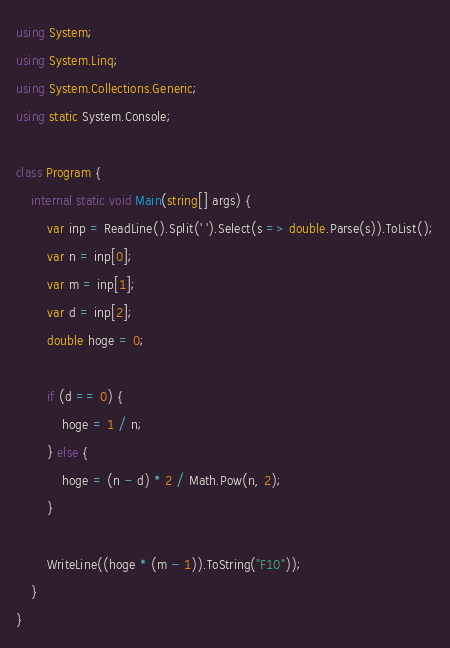<code> <loc_0><loc_0><loc_500><loc_500><_C#_>using System;
using System.Linq;
using System.Collections.Generic;
using static System.Console;

class Program {
    internal static void Main(string[] args) {
        var inp = ReadLine().Split(' ').Select(s => double.Parse(s)).ToList();
        var n = inp[0];
        var m = inp[1];
        var d = inp[2];
        double hoge = 0;

        if (d == 0) {
            hoge = 1 / n;
        } else {
            hoge = (n - d) * 2 / Math.Pow(n, 2);
        }

        WriteLine((hoge * (m - 1)).ToString("F10"));
    }
}
</code> 